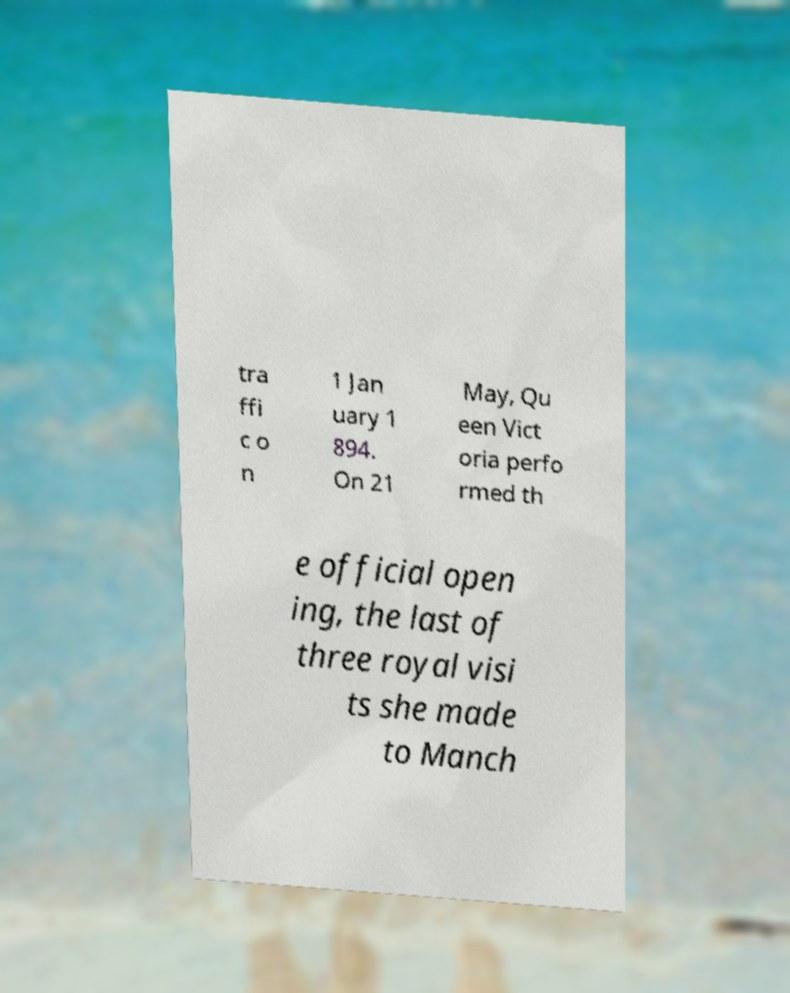I need the written content from this picture converted into text. Can you do that? tra ffi c o n 1 Jan uary 1 894. On 21 May, Qu een Vict oria perfo rmed th e official open ing, the last of three royal visi ts she made to Manch 